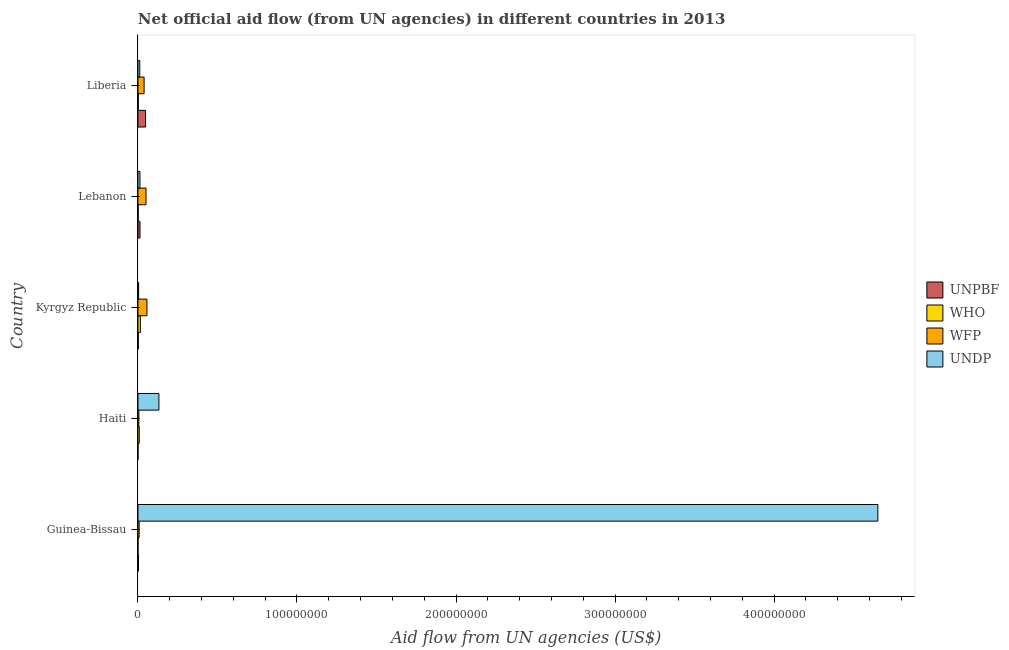Are the number of bars per tick equal to the number of legend labels?
Offer a very short reply. Yes. Are the number of bars on each tick of the Y-axis equal?
Ensure brevity in your answer.  Yes. What is the label of the 2nd group of bars from the top?
Give a very brief answer. Lebanon. In how many cases, is the number of bars for a given country not equal to the number of legend labels?
Your answer should be compact. 0. What is the amount of aid given by undp in Liberia?
Offer a very short reply. 1.15e+06. Across all countries, what is the maximum amount of aid given by unpbf?
Offer a terse response. 4.76e+06. Across all countries, what is the minimum amount of aid given by wfp?
Your answer should be compact. 5.70e+05. In which country was the amount of aid given by undp maximum?
Give a very brief answer. Guinea-Bissau. In which country was the amount of aid given by wfp minimum?
Keep it short and to the point. Haiti. What is the total amount of aid given by undp in the graph?
Offer a very short reply. 4.81e+08. What is the difference between the amount of aid given by who in Haiti and that in Liberia?
Your answer should be compact. 5.80e+05. What is the difference between the amount of aid given by undp in Liberia and the amount of aid given by unpbf in Guinea-Bissau?
Make the answer very short. 8.50e+05. What is the average amount of aid given by undp per country?
Give a very brief answer. 9.63e+07. What is the difference between the amount of aid given by wfp and amount of aid given by undp in Kyrgyz Republic?
Your answer should be compact. 5.21e+06. What is the ratio of the amount of aid given by wfp in Guinea-Bissau to that in Liberia?
Give a very brief answer. 0.19. What is the difference between the highest and the second highest amount of aid given by undp?
Ensure brevity in your answer.  4.52e+08. What is the difference between the highest and the lowest amount of aid given by undp?
Your answer should be very brief. 4.65e+08. In how many countries, is the amount of aid given by unpbf greater than the average amount of aid given by unpbf taken over all countries?
Give a very brief answer. 1. Is the sum of the amount of aid given by undp in Guinea-Bissau and Lebanon greater than the maximum amount of aid given by who across all countries?
Offer a very short reply. Yes. Is it the case that in every country, the sum of the amount of aid given by unpbf and amount of aid given by who is greater than the sum of amount of aid given by undp and amount of aid given by wfp?
Make the answer very short. No. What does the 3rd bar from the top in Lebanon represents?
Give a very brief answer. WHO. What does the 2nd bar from the bottom in Kyrgyz Republic represents?
Provide a succinct answer. WHO. Is it the case that in every country, the sum of the amount of aid given by unpbf and amount of aid given by who is greater than the amount of aid given by wfp?
Your answer should be compact. No. How many bars are there?
Give a very brief answer. 20. How many countries are there in the graph?
Offer a terse response. 5. What is the difference between two consecutive major ticks on the X-axis?
Your answer should be very brief. 1.00e+08. Does the graph contain any zero values?
Give a very brief answer. No. What is the title of the graph?
Your answer should be very brief. Net official aid flow (from UN agencies) in different countries in 2013. Does "Energy" appear as one of the legend labels in the graph?
Your answer should be compact. No. What is the label or title of the X-axis?
Your answer should be compact. Aid flow from UN agencies (US$). What is the label or title of the Y-axis?
Your answer should be very brief. Country. What is the Aid flow from UN agencies (US$) in UNPBF in Guinea-Bissau?
Your answer should be very brief. 3.00e+05. What is the Aid flow from UN agencies (US$) of WHO in Guinea-Bissau?
Your response must be concise. 3.00e+04. What is the Aid flow from UN agencies (US$) of WFP in Guinea-Bissau?
Make the answer very short. 7.40e+05. What is the Aid flow from UN agencies (US$) of UNDP in Guinea-Bissau?
Your answer should be compact. 4.65e+08. What is the Aid flow from UN agencies (US$) of UNPBF in Haiti?
Provide a succinct answer. 2.00e+04. What is the Aid flow from UN agencies (US$) of WFP in Haiti?
Provide a short and direct response. 5.70e+05. What is the Aid flow from UN agencies (US$) in UNDP in Haiti?
Provide a succinct answer. 1.32e+07. What is the Aid flow from UN agencies (US$) of UNPBF in Kyrgyz Republic?
Your answer should be compact. 2.00e+05. What is the Aid flow from UN agencies (US$) in WHO in Kyrgyz Republic?
Your answer should be very brief. 1.50e+06. What is the Aid flow from UN agencies (US$) of WFP in Kyrgyz Republic?
Ensure brevity in your answer.  5.64e+06. What is the Aid flow from UN agencies (US$) of UNPBF in Lebanon?
Offer a very short reply. 1.27e+06. What is the Aid flow from UN agencies (US$) of WHO in Lebanon?
Keep it short and to the point. 1.30e+05. What is the Aid flow from UN agencies (US$) in WFP in Lebanon?
Your answer should be compact. 5.07e+06. What is the Aid flow from UN agencies (US$) in UNDP in Lebanon?
Keep it short and to the point. 1.26e+06. What is the Aid flow from UN agencies (US$) in UNPBF in Liberia?
Your answer should be compact. 4.76e+06. What is the Aid flow from UN agencies (US$) of WFP in Liberia?
Offer a terse response. 3.86e+06. What is the Aid flow from UN agencies (US$) of UNDP in Liberia?
Your response must be concise. 1.15e+06. Across all countries, what is the maximum Aid flow from UN agencies (US$) of UNPBF?
Your answer should be compact. 4.76e+06. Across all countries, what is the maximum Aid flow from UN agencies (US$) of WHO?
Offer a very short reply. 1.50e+06. Across all countries, what is the maximum Aid flow from UN agencies (US$) of WFP?
Offer a terse response. 5.64e+06. Across all countries, what is the maximum Aid flow from UN agencies (US$) in UNDP?
Your response must be concise. 4.65e+08. Across all countries, what is the minimum Aid flow from UN agencies (US$) of WFP?
Offer a terse response. 5.70e+05. Across all countries, what is the minimum Aid flow from UN agencies (US$) of UNDP?
Keep it short and to the point. 4.30e+05. What is the total Aid flow from UN agencies (US$) in UNPBF in the graph?
Make the answer very short. 6.55e+06. What is the total Aid flow from UN agencies (US$) in WHO in the graph?
Provide a succinct answer. 2.68e+06. What is the total Aid flow from UN agencies (US$) in WFP in the graph?
Your answer should be very brief. 1.59e+07. What is the total Aid flow from UN agencies (US$) of UNDP in the graph?
Give a very brief answer. 4.81e+08. What is the difference between the Aid flow from UN agencies (US$) in WHO in Guinea-Bissau and that in Haiti?
Ensure brevity in your answer.  -7.70e+05. What is the difference between the Aid flow from UN agencies (US$) of WFP in Guinea-Bissau and that in Haiti?
Your answer should be compact. 1.70e+05. What is the difference between the Aid flow from UN agencies (US$) in UNDP in Guinea-Bissau and that in Haiti?
Provide a succinct answer. 4.52e+08. What is the difference between the Aid flow from UN agencies (US$) in WHO in Guinea-Bissau and that in Kyrgyz Republic?
Keep it short and to the point. -1.47e+06. What is the difference between the Aid flow from UN agencies (US$) in WFP in Guinea-Bissau and that in Kyrgyz Republic?
Your answer should be compact. -4.90e+06. What is the difference between the Aid flow from UN agencies (US$) of UNDP in Guinea-Bissau and that in Kyrgyz Republic?
Keep it short and to the point. 4.65e+08. What is the difference between the Aid flow from UN agencies (US$) of UNPBF in Guinea-Bissau and that in Lebanon?
Keep it short and to the point. -9.70e+05. What is the difference between the Aid flow from UN agencies (US$) in WHO in Guinea-Bissau and that in Lebanon?
Keep it short and to the point. -1.00e+05. What is the difference between the Aid flow from UN agencies (US$) in WFP in Guinea-Bissau and that in Lebanon?
Make the answer very short. -4.33e+06. What is the difference between the Aid flow from UN agencies (US$) in UNDP in Guinea-Bissau and that in Lebanon?
Your answer should be compact. 4.64e+08. What is the difference between the Aid flow from UN agencies (US$) of UNPBF in Guinea-Bissau and that in Liberia?
Your answer should be very brief. -4.46e+06. What is the difference between the Aid flow from UN agencies (US$) in WFP in Guinea-Bissau and that in Liberia?
Offer a very short reply. -3.12e+06. What is the difference between the Aid flow from UN agencies (US$) of UNDP in Guinea-Bissau and that in Liberia?
Your answer should be compact. 4.64e+08. What is the difference between the Aid flow from UN agencies (US$) of UNPBF in Haiti and that in Kyrgyz Republic?
Provide a short and direct response. -1.80e+05. What is the difference between the Aid flow from UN agencies (US$) in WHO in Haiti and that in Kyrgyz Republic?
Make the answer very short. -7.00e+05. What is the difference between the Aid flow from UN agencies (US$) in WFP in Haiti and that in Kyrgyz Republic?
Offer a very short reply. -5.07e+06. What is the difference between the Aid flow from UN agencies (US$) in UNDP in Haiti and that in Kyrgyz Republic?
Your answer should be compact. 1.27e+07. What is the difference between the Aid flow from UN agencies (US$) in UNPBF in Haiti and that in Lebanon?
Keep it short and to the point. -1.25e+06. What is the difference between the Aid flow from UN agencies (US$) of WHO in Haiti and that in Lebanon?
Your answer should be very brief. 6.70e+05. What is the difference between the Aid flow from UN agencies (US$) in WFP in Haiti and that in Lebanon?
Your answer should be compact. -4.50e+06. What is the difference between the Aid flow from UN agencies (US$) in UNDP in Haiti and that in Lebanon?
Offer a terse response. 1.19e+07. What is the difference between the Aid flow from UN agencies (US$) in UNPBF in Haiti and that in Liberia?
Ensure brevity in your answer.  -4.74e+06. What is the difference between the Aid flow from UN agencies (US$) in WHO in Haiti and that in Liberia?
Provide a succinct answer. 5.80e+05. What is the difference between the Aid flow from UN agencies (US$) in WFP in Haiti and that in Liberia?
Provide a succinct answer. -3.29e+06. What is the difference between the Aid flow from UN agencies (US$) in UNDP in Haiti and that in Liberia?
Keep it short and to the point. 1.20e+07. What is the difference between the Aid flow from UN agencies (US$) in UNPBF in Kyrgyz Republic and that in Lebanon?
Offer a very short reply. -1.07e+06. What is the difference between the Aid flow from UN agencies (US$) of WHO in Kyrgyz Republic and that in Lebanon?
Ensure brevity in your answer.  1.37e+06. What is the difference between the Aid flow from UN agencies (US$) in WFP in Kyrgyz Republic and that in Lebanon?
Provide a succinct answer. 5.70e+05. What is the difference between the Aid flow from UN agencies (US$) of UNDP in Kyrgyz Republic and that in Lebanon?
Give a very brief answer. -8.30e+05. What is the difference between the Aid flow from UN agencies (US$) in UNPBF in Kyrgyz Republic and that in Liberia?
Ensure brevity in your answer.  -4.56e+06. What is the difference between the Aid flow from UN agencies (US$) in WHO in Kyrgyz Republic and that in Liberia?
Make the answer very short. 1.28e+06. What is the difference between the Aid flow from UN agencies (US$) in WFP in Kyrgyz Republic and that in Liberia?
Offer a terse response. 1.78e+06. What is the difference between the Aid flow from UN agencies (US$) of UNDP in Kyrgyz Republic and that in Liberia?
Ensure brevity in your answer.  -7.20e+05. What is the difference between the Aid flow from UN agencies (US$) in UNPBF in Lebanon and that in Liberia?
Keep it short and to the point. -3.49e+06. What is the difference between the Aid flow from UN agencies (US$) of WHO in Lebanon and that in Liberia?
Your response must be concise. -9.00e+04. What is the difference between the Aid flow from UN agencies (US$) in WFP in Lebanon and that in Liberia?
Offer a very short reply. 1.21e+06. What is the difference between the Aid flow from UN agencies (US$) of UNPBF in Guinea-Bissau and the Aid flow from UN agencies (US$) of WHO in Haiti?
Your answer should be compact. -5.00e+05. What is the difference between the Aid flow from UN agencies (US$) in UNPBF in Guinea-Bissau and the Aid flow from UN agencies (US$) in UNDP in Haiti?
Make the answer very short. -1.29e+07. What is the difference between the Aid flow from UN agencies (US$) of WHO in Guinea-Bissau and the Aid flow from UN agencies (US$) of WFP in Haiti?
Give a very brief answer. -5.40e+05. What is the difference between the Aid flow from UN agencies (US$) in WHO in Guinea-Bissau and the Aid flow from UN agencies (US$) in UNDP in Haiti?
Provide a succinct answer. -1.31e+07. What is the difference between the Aid flow from UN agencies (US$) of WFP in Guinea-Bissau and the Aid flow from UN agencies (US$) of UNDP in Haiti?
Your answer should be compact. -1.24e+07. What is the difference between the Aid flow from UN agencies (US$) of UNPBF in Guinea-Bissau and the Aid flow from UN agencies (US$) of WHO in Kyrgyz Republic?
Your response must be concise. -1.20e+06. What is the difference between the Aid flow from UN agencies (US$) in UNPBF in Guinea-Bissau and the Aid flow from UN agencies (US$) in WFP in Kyrgyz Republic?
Offer a very short reply. -5.34e+06. What is the difference between the Aid flow from UN agencies (US$) of UNPBF in Guinea-Bissau and the Aid flow from UN agencies (US$) of UNDP in Kyrgyz Republic?
Ensure brevity in your answer.  -1.30e+05. What is the difference between the Aid flow from UN agencies (US$) of WHO in Guinea-Bissau and the Aid flow from UN agencies (US$) of WFP in Kyrgyz Republic?
Offer a very short reply. -5.61e+06. What is the difference between the Aid flow from UN agencies (US$) in WHO in Guinea-Bissau and the Aid flow from UN agencies (US$) in UNDP in Kyrgyz Republic?
Your answer should be very brief. -4.00e+05. What is the difference between the Aid flow from UN agencies (US$) in WFP in Guinea-Bissau and the Aid flow from UN agencies (US$) in UNDP in Kyrgyz Republic?
Make the answer very short. 3.10e+05. What is the difference between the Aid flow from UN agencies (US$) in UNPBF in Guinea-Bissau and the Aid flow from UN agencies (US$) in WHO in Lebanon?
Make the answer very short. 1.70e+05. What is the difference between the Aid flow from UN agencies (US$) in UNPBF in Guinea-Bissau and the Aid flow from UN agencies (US$) in WFP in Lebanon?
Your response must be concise. -4.77e+06. What is the difference between the Aid flow from UN agencies (US$) of UNPBF in Guinea-Bissau and the Aid flow from UN agencies (US$) of UNDP in Lebanon?
Keep it short and to the point. -9.60e+05. What is the difference between the Aid flow from UN agencies (US$) in WHO in Guinea-Bissau and the Aid flow from UN agencies (US$) in WFP in Lebanon?
Provide a succinct answer. -5.04e+06. What is the difference between the Aid flow from UN agencies (US$) of WHO in Guinea-Bissau and the Aid flow from UN agencies (US$) of UNDP in Lebanon?
Offer a terse response. -1.23e+06. What is the difference between the Aid flow from UN agencies (US$) in WFP in Guinea-Bissau and the Aid flow from UN agencies (US$) in UNDP in Lebanon?
Keep it short and to the point. -5.20e+05. What is the difference between the Aid flow from UN agencies (US$) in UNPBF in Guinea-Bissau and the Aid flow from UN agencies (US$) in WHO in Liberia?
Your answer should be very brief. 8.00e+04. What is the difference between the Aid flow from UN agencies (US$) in UNPBF in Guinea-Bissau and the Aid flow from UN agencies (US$) in WFP in Liberia?
Keep it short and to the point. -3.56e+06. What is the difference between the Aid flow from UN agencies (US$) in UNPBF in Guinea-Bissau and the Aid flow from UN agencies (US$) in UNDP in Liberia?
Your answer should be very brief. -8.50e+05. What is the difference between the Aid flow from UN agencies (US$) in WHO in Guinea-Bissau and the Aid flow from UN agencies (US$) in WFP in Liberia?
Offer a very short reply. -3.83e+06. What is the difference between the Aid flow from UN agencies (US$) of WHO in Guinea-Bissau and the Aid flow from UN agencies (US$) of UNDP in Liberia?
Give a very brief answer. -1.12e+06. What is the difference between the Aid flow from UN agencies (US$) in WFP in Guinea-Bissau and the Aid flow from UN agencies (US$) in UNDP in Liberia?
Your answer should be compact. -4.10e+05. What is the difference between the Aid flow from UN agencies (US$) of UNPBF in Haiti and the Aid flow from UN agencies (US$) of WHO in Kyrgyz Republic?
Provide a short and direct response. -1.48e+06. What is the difference between the Aid flow from UN agencies (US$) in UNPBF in Haiti and the Aid flow from UN agencies (US$) in WFP in Kyrgyz Republic?
Provide a short and direct response. -5.62e+06. What is the difference between the Aid flow from UN agencies (US$) in UNPBF in Haiti and the Aid flow from UN agencies (US$) in UNDP in Kyrgyz Republic?
Your response must be concise. -4.10e+05. What is the difference between the Aid flow from UN agencies (US$) in WHO in Haiti and the Aid flow from UN agencies (US$) in WFP in Kyrgyz Republic?
Your response must be concise. -4.84e+06. What is the difference between the Aid flow from UN agencies (US$) in UNPBF in Haiti and the Aid flow from UN agencies (US$) in WFP in Lebanon?
Provide a short and direct response. -5.05e+06. What is the difference between the Aid flow from UN agencies (US$) in UNPBF in Haiti and the Aid flow from UN agencies (US$) in UNDP in Lebanon?
Offer a very short reply. -1.24e+06. What is the difference between the Aid flow from UN agencies (US$) in WHO in Haiti and the Aid flow from UN agencies (US$) in WFP in Lebanon?
Provide a succinct answer. -4.27e+06. What is the difference between the Aid flow from UN agencies (US$) in WHO in Haiti and the Aid flow from UN agencies (US$) in UNDP in Lebanon?
Provide a succinct answer. -4.60e+05. What is the difference between the Aid flow from UN agencies (US$) of WFP in Haiti and the Aid flow from UN agencies (US$) of UNDP in Lebanon?
Make the answer very short. -6.90e+05. What is the difference between the Aid flow from UN agencies (US$) of UNPBF in Haiti and the Aid flow from UN agencies (US$) of WFP in Liberia?
Offer a terse response. -3.84e+06. What is the difference between the Aid flow from UN agencies (US$) in UNPBF in Haiti and the Aid flow from UN agencies (US$) in UNDP in Liberia?
Offer a very short reply. -1.13e+06. What is the difference between the Aid flow from UN agencies (US$) of WHO in Haiti and the Aid flow from UN agencies (US$) of WFP in Liberia?
Your answer should be very brief. -3.06e+06. What is the difference between the Aid flow from UN agencies (US$) of WHO in Haiti and the Aid flow from UN agencies (US$) of UNDP in Liberia?
Keep it short and to the point. -3.50e+05. What is the difference between the Aid flow from UN agencies (US$) of WFP in Haiti and the Aid flow from UN agencies (US$) of UNDP in Liberia?
Ensure brevity in your answer.  -5.80e+05. What is the difference between the Aid flow from UN agencies (US$) of UNPBF in Kyrgyz Republic and the Aid flow from UN agencies (US$) of WFP in Lebanon?
Your answer should be compact. -4.87e+06. What is the difference between the Aid flow from UN agencies (US$) of UNPBF in Kyrgyz Republic and the Aid flow from UN agencies (US$) of UNDP in Lebanon?
Make the answer very short. -1.06e+06. What is the difference between the Aid flow from UN agencies (US$) in WHO in Kyrgyz Republic and the Aid flow from UN agencies (US$) in WFP in Lebanon?
Provide a short and direct response. -3.57e+06. What is the difference between the Aid flow from UN agencies (US$) in WHO in Kyrgyz Republic and the Aid flow from UN agencies (US$) in UNDP in Lebanon?
Offer a very short reply. 2.40e+05. What is the difference between the Aid flow from UN agencies (US$) in WFP in Kyrgyz Republic and the Aid flow from UN agencies (US$) in UNDP in Lebanon?
Your response must be concise. 4.38e+06. What is the difference between the Aid flow from UN agencies (US$) in UNPBF in Kyrgyz Republic and the Aid flow from UN agencies (US$) in WHO in Liberia?
Your answer should be very brief. -2.00e+04. What is the difference between the Aid flow from UN agencies (US$) in UNPBF in Kyrgyz Republic and the Aid flow from UN agencies (US$) in WFP in Liberia?
Offer a very short reply. -3.66e+06. What is the difference between the Aid flow from UN agencies (US$) of UNPBF in Kyrgyz Republic and the Aid flow from UN agencies (US$) of UNDP in Liberia?
Ensure brevity in your answer.  -9.50e+05. What is the difference between the Aid flow from UN agencies (US$) of WHO in Kyrgyz Republic and the Aid flow from UN agencies (US$) of WFP in Liberia?
Give a very brief answer. -2.36e+06. What is the difference between the Aid flow from UN agencies (US$) in WFP in Kyrgyz Republic and the Aid flow from UN agencies (US$) in UNDP in Liberia?
Provide a short and direct response. 4.49e+06. What is the difference between the Aid flow from UN agencies (US$) in UNPBF in Lebanon and the Aid flow from UN agencies (US$) in WHO in Liberia?
Ensure brevity in your answer.  1.05e+06. What is the difference between the Aid flow from UN agencies (US$) of UNPBF in Lebanon and the Aid flow from UN agencies (US$) of WFP in Liberia?
Offer a terse response. -2.59e+06. What is the difference between the Aid flow from UN agencies (US$) of UNPBF in Lebanon and the Aid flow from UN agencies (US$) of UNDP in Liberia?
Your response must be concise. 1.20e+05. What is the difference between the Aid flow from UN agencies (US$) of WHO in Lebanon and the Aid flow from UN agencies (US$) of WFP in Liberia?
Your answer should be compact. -3.73e+06. What is the difference between the Aid flow from UN agencies (US$) of WHO in Lebanon and the Aid flow from UN agencies (US$) of UNDP in Liberia?
Your answer should be compact. -1.02e+06. What is the difference between the Aid flow from UN agencies (US$) in WFP in Lebanon and the Aid flow from UN agencies (US$) in UNDP in Liberia?
Make the answer very short. 3.92e+06. What is the average Aid flow from UN agencies (US$) in UNPBF per country?
Offer a very short reply. 1.31e+06. What is the average Aid flow from UN agencies (US$) of WHO per country?
Ensure brevity in your answer.  5.36e+05. What is the average Aid flow from UN agencies (US$) of WFP per country?
Your answer should be compact. 3.18e+06. What is the average Aid flow from UN agencies (US$) of UNDP per country?
Your answer should be compact. 9.63e+07. What is the difference between the Aid flow from UN agencies (US$) of UNPBF and Aid flow from UN agencies (US$) of WHO in Guinea-Bissau?
Your answer should be very brief. 2.70e+05. What is the difference between the Aid flow from UN agencies (US$) in UNPBF and Aid flow from UN agencies (US$) in WFP in Guinea-Bissau?
Offer a terse response. -4.40e+05. What is the difference between the Aid flow from UN agencies (US$) in UNPBF and Aid flow from UN agencies (US$) in UNDP in Guinea-Bissau?
Provide a succinct answer. -4.65e+08. What is the difference between the Aid flow from UN agencies (US$) in WHO and Aid flow from UN agencies (US$) in WFP in Guinea-Bissau?
Your answer should be compact. -7.10e+05. What is the difference between the Aid flow from UN agencies (US$) in WHO and Aid flow from UN agencies (US$) in UNDP in Guinea-Bissau?
Make the answer very short. -4.65e+08. What is the difference between the Aid flow from UN agencies (US$) in WFP and Aid flow from UN agencies (US$) in UNDP in Guinea-Bissau?
Keep it short and to the point. -4.65e+08. What is the difference between the Aid flow from UN agencies (US$) in UNPBF and Aid flow from UN agencies (US$) in WHO in Haiti?
Your response must be concise. -7.80e+05. What is the difference between the Aid flow from UN agencies (US$) in UNPBF and Aid flow from UN agencies (US$) in WFP in Haiti?
Your answer should be very brief. -5.50e+05. What is the difference between the Aid flow from UN agencies (US$) of UNPBF and Aid flow from UN agencies (US$) of UNDP in Haiti?
Give a very brief answer. -1.32e+07. What is the difference between the Aid flow from UN agencies (US$) in WHO and Aid flow from UN agencies (US$) in UNDP in Haiti?
Your response must be concise. -1.24e+07. What is the difference between the Aid flow from UN agencies (US$) of WFP and Aid flow from UN agencies (US$) of UNDP in Haiti?
Provide a succinct answer. -1.26e+07. What is the difference between the Aid flow from UN agencies (US$) in UNPBF and Aid flow from UN agencies (US$) in WHO in Kyrgyz Republic?
Provide a succinct answer. -1.30e+06. What is the difference between the Aid flow from UN agencies (US$) of UNPBF and Aid flow from UN agencies (US$) of WFP in Kyrgyz Republic?
Your response must be concise. -5.44e+06. What is the difference between the Aid flow from UN agencies (US$) of UNPBF and Aid flow from UN agencies (US$) of UNDP in Kyrgyz Republic?
Your answer should be very brief. -2.30e+05. What is the difference between the Aid flow from UN agencies (US$) in WHO and Aid flow from UN agencies (US$) in WFP in Kyrgyz Republic?
Keep it short and to the point. -4.14e+06. What is the difference between the Aid flow from UN agencies (US$) of WHO and Aid flow from UN agencies (US$) of UNDP in Kyrgyz Republic?
Ensure brevity in your answer.  1.07e+06. What is the difference between the Aid flow from UN agencies (US$) of WFP and Aid flow from UN agencies (US$) of UNDP in Kyrgyz Republic?
Make the answer very short. 5.21e+06. What is the difference between the Aid flow from UN agencies (US$) in UNPBF and Aid flow from UN agencies (US$) in WHO in Lebanon?
Offer a very short reply. 1.14e+06. What is the difference between the Aid flow from UN agencies (US$) of UNPBF and Aid flow from UN agencies (US$) of WFP in Lebanon?
Make the answer very short. -3.80e+06. What is the difference between the Aid flow from UN agencies (US$) of UNPBF and Aid flow from UN agencies (US$) of UNDP in Lebanon?
Your answer should be very brief. 10000. What is the difference between the Aid flow from UN agencies (US$) of WHO and Aid flow from UN agencies (US$) of WFP in Lebanon?
Offer a terse response. -4.94e+06. What is the difference between the Aid flow from UN agencies (US$) in WHO and Aid flow from UN agencies (US$) in UNDP in Lebanon?
Provide a short and direct response. -1.13e+06. What is the difference between the Aid flow from UN agencies (US$) in WFP and Aid flow from UN agencies (US$) in UNDP in Lebanon?
Provide a short and direct response. 3.81e+06. What is the difference between the Aid flow from UN agencies (US$) of UNPBF and Aid flow from UN agencies (US$) of WHO in Liberia?
Give a very brief answer. 4.54e+06. What is the difference between the Aid flow from UN agencies (US$) in UNPBF and Aid flow from UN agencies (US$) in WFP in Liberia?
Your response must be concise. 9.00e+05. What is the difference between the Aid flow from UN agencies (US$) of UNPBF and Aid flow from UN agencies (US$) of UNDP in Liberia?
Ensure brevity in your answer.  3.61e+06. What is the difference between the Aid flow from UN agencies (US$) of WHO and Aid flow from UN agencies (US$) of WFP in Liberia?
Provide a short and direct response. -3.64e+06. What is the difference between the Aid flow from UN agencies (US$) of WHO and Aid flow from UN agencies (US$) of UNDP in Liberia?
Your response must be concise. -9.30e+05. What is the difference between the Aid flow from UN agencies (US$) in WFP and Aid flow from UN agencies (US$) in UNDP in Liberia?
Make the answer very short. 2.71e+06. What is the ratio of the Aid flow from UN agencies (US$) of WHO in Guinea-Bissau to that in Haiti?
Provide a short and direct response. 0.04. What is the ratio of the Aid flow from UN agencies (US$) in WFP in Guinea-Bissau to that in Haiti?
Keep it short and to the point. 1.3. What is the ratio of the Aid flow from UN agencies (US$) of UNDP in Guinea-Bissau to that in Haiti?
Ensure brevity in your answer.  35.33. What is the ratio of the Aid flow from UN agencies (US$) of WHO in Guinea-Bissau to that in Kyrgyz Republic?
Ensure brevity in your answer.  0.02. What is the ratio of the Aid flow from UN agencies (US$) in WFP in Guinea-Bissau to that in Kyrgyz Republic?
Your response must be concise. 0.13. What is the ratio of the Aid flow from UN agencies (US$) in UNDP in Guinea-Bissau to that in Kyrgyz Republic?
Your answer should be very brief. 1082. What is the ratio of the Aid flow from UN agencies (US$) of UNPBF in Guinea-Bissau to that in Lebanon?
Your response must be concise. 0.24. What is the ratio of the Aid flow from UN agencies (US$) of WHO in Guinea-Bissau to that in Lebanon?
Provide a short and direct response. 0.23. What is the ratio of the Aid flow from UN agencies (US$) in WFP in Guinea-Bissau to that in Lebanon?
Offer a terse response. 0.15. What is the ratio of the Aid flow from UN agencies (US$) in UNDP in Guinea-Bissau to that in Lebanon?
Provide a short and direct response. 369.25. What is the ratio of the Aid flow from UN agencies (US$) in UNPBF in Guinea-Bissau to that in Liberia?
Provide a short and direct response. 0.06. What is the ratio of the Aid flow from UN agencies (US$) in WHO in Guinea-Bissau to that in Liberia?
Your answer should be compact. 0.14. What is the ratio of the Aid flow from UN agencies (US$) of WFP in Guinea-Bissau to that in Liberia?
Make the answer very short. 0.19. What is the ratio of the Aid flow from UN agencies (US$) in UNDP in Guinea-Bissau to that in Liberia?
Give a very brief answer. 404.57. What is the ratio of the Aid flow from UN agencies (US$) in UNPBF in Haiti to that in Kyrgyz Republic?
Make the answer very short. 0.1. What is the ratio of the Aid flow from UN agencies (US$) of WHO in Haiti to that in Kyrgyz Republic?
Give a very brief answer. 0.53. What is the ratio of the Aid flow from UN agencies (US$) in WFP in Haiti to that in Kyrgyz Republic?
Give a very brief answer. 0.1. What is the ratio of the Aid flow from UN agencies (US$) of UNDP in Haiti to that in Kyrgyz Republic?
Make the answer very short. 30.63. What is the ratio of the Aid flow from UN agencies (US$) of UNPBF in Haiti to that in Lebanon?
Provide a short and direct response. 0.02. What is the ratio of the Aid flow from UN agencies (US$) in WHO in Haiti to that in Lebanon?
Offer a terse response. 6.15. What is the ratio of the Aid flow from UN agencies (US$) of WFP in Haiti to that in Lebanon?
Your answer should be compact. 0.11. What is the ratio of the Aid flow from UN agencies (US$) of UNDP in Haiti to that in Lebanon?
Ensure brevity in your answer.  10.45. What is the ratio of the Aid flow from UN agencies (US$) of UNPBF in Haiti to that in Liberia?
Give a very brief answer. 0. What is the ratio of the Aid flow from UN agencies (US$) of WHO in Haiti to that in Liberia?
Provide a short and direct response. 3.64. What is the ratio of the Aid flow from UN agencies (US$) of WFP in Haiti to that in Liberia?
Provide a succinct answer. 0.15. What is the ratio of the Aid flow from UN agencies (US$) of UNDP in Haiti to that in Liberia?
Provide a short and direct response. 11.45. What is the ratio of the Aid flow from UN agencies (US$) of UNPBF in Kyrgyz Republic to that in Lebanon?
Your answer should be compact. 0.16. What is the ratio of the Aid flow from UN agencies (US$) of WHO in Kyrgyz Republic to that in Lebanon?
Provide a short and direct response. 11.54. What is the ratio of the Aid flow from UN agencies (US$) of WFP in Kyrgyz Republic to that in Lebanon?
Offer a terse response. 1.11. What is the ratio of the Aid flow from UN agencies (US$) of UNDP in Kyrgyz Republic to that in Lebanon?
Provide a short and direct response. 0.34. What is the ratio of the Aid flow from UN agencies (US$) in UNPBF in Kyrgyz Republic to that in Liberia?
Offer a terse response. 0.04. What is the ratio of the Aid flow from UN agencies (US$) in WHO in Kyrgyz Republic to that in Liberia?
Provide a succinct answer. 6.82. What is the ratio of the Aid flow from UN agencies (US$) of WFP in Kyrgyz Republic to that in Liberia?
Keep it short and to the point. 1.46. What is the ratio of the Aid flow from UN agencies (US$) of UNDP in Kyrgyz Republic to that in Liberia?
Make the answer very short. 0.37. What is the ratio of the Aid flow from UN agencies (US$) of UNPBF in Lebanon to that in Liberia?
Give a very brief answer. 0.27. What is the ratio of the Aid flow from UN agencies (US$) in WHO in Lebanon to that in Liberia?
Your response must be concise. 0.59. What is the ratio of the Aid flow from UN agencies (US$) of WFP in Lebanon to that in Liberia?
Your response must be concise. 1.31. What is the ratio of the Aid flow from UN agencies (US$) of UNDP in Lebanon to that in Liberia?
Keep it short and to the point. 1.1. What is the difference between the highest and the second highest Aid flow from UN agencies (US$) in UNPBF?
Keep it short and to the point. 3.49e+06. What is the difference between the highest and the second highest Aid flow from UN agencies (US$) in WFP?
Provide a short and direct response. 5.70e+05. What is the difference between the highest and the second highest Aid flow from UN agencies (US$) of UNDP?
Provide a succinct answer. 4.52e+08. What is the difference between the highest and the lowest Aid flow from UN agencies (US$) in UNPBF?
Provide a short and direct response. 4.74e+06. What is the difference between the highest and the lowest Aid flow from UN agencies (US$) of WHO?
Offer a terse response. 1.47e+06. What is the difference between the highest and the lowest Aid flow from UN agencies (US$) in WFP?
Keep it short and to the point. 5.07e+06. What is the difference between the highest and the lowest Aid flow from UN agencies (US$) of UNDP?
Ensure brevity in your answer.  4.65e+08. 